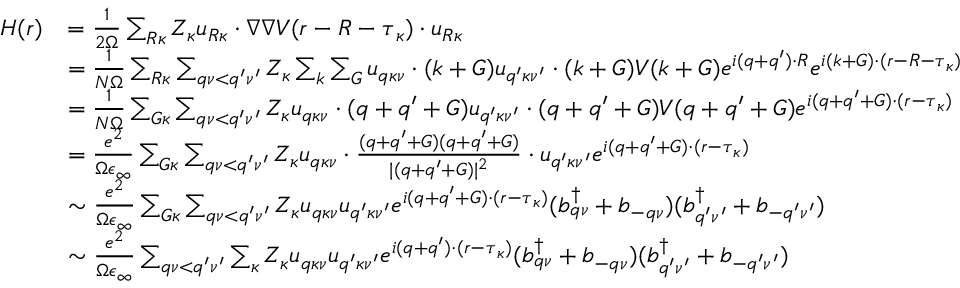<formula> <loc_0><loc_0><loc_500><loc_500>\begin{array} { r l } { H ( r ) } & { = \frac { 1 } { 2 \Omega } \sum _ { R \kappa } Z _ { \kappa } u _ { R \kappa } \cdot \nabla \nabla V ( r - R - \tau _ { \kappa } ) \cdot u _ { R \kappa } } \\ & { = \frac { 1 } { N \Omega } \sum _ { R \kappa } \sum _ { q \nu < q ^ { \prime } \nu ^ { \prime } } Z _ { \kappa } \sum _ { k } \sum _ { G } u _ { q \kappa \nu } \cdot ( k + G ) u _ { q ^ { \prime } \kappa \nu ^ { \prime } } \cdot ( k + G ) V ( k + G ) e ^ { i ( q + q ^ { \prime } ) \cdot R } e ^ { i ( k + G ) \cdot ( r - R - \tau _ { \kappa } ) } } \\ & { = \frac { 1 } { N \Omega } \sum _ { G \kappa } \sum _ { q \nu < q ^ { \prime } \nu ^ { \prime } } Z _ { \kappa } u _ { q \kappa \nu } \cdot ( q + q ^ { \prime } + G ) u _ { q ^ { \prime } \kappa \nu ^ { \prime } } \cdot ( q + q ^ { \prime } + G ) V ( q + q ^ { \prime } + G ) e ^ { i ( q + q ^ { \prime } + G ) \cdot ( r - \tau _ { \kappa } ) } } \\ & { = \frac { e ^ { 2 } } { \Omega \epsilon _ { \infty } } \sum _ { G \kappa } \sum _ { q \nu < q ^ { \prime } \nu ^ { \prime } } Z _ { \kappa } u _ { q \kappa \nu } \cdot \frac { ( q + q ^ { \prime } + G ) ( q + q ^ { \prime } + G ) } { | ( q + q ^ { \prime } + G ) | ^ { 2 } } \cdot u _ { q ^ { \prime } \kappa \nu ^ { \prime } } e ^ { i ( q + q ^ { \prime } + G ) \cdot ( r - \tau _ { \kappa } ) } } \\ & { \sim \frac { e ^ { 2 } } { \Omega \epsilon _ { \infty } } \sum _ { G \kappa } \sum _ { q \nu < q ^ { \prime } \nu ^ { \prime } } Z _ { \kappa } u _ { q \kappa \nu } u _ { q ^ { \prime } \kappa \nu ^ { \prime } } e ^ { i ( q + q ^ { \prime } + G ) \cdot ( r - \tau _ { \kappa } ) } ( b _ { q \nu } ^ { \dagger } + b _ { - q \nu } ) ( b _ { q ^ { \prime } \nu ^ { \prime } } ^ { \dagger } + b _ { - q ^ { \prime } \nu ^ { \prime } } ) } \\ & { \sim \frac { e ^ { 2 } } { \Omega \epsilon _ { \infty } } \sum _ { q \nu < q ^ { \prime } \nu ^ { \prime } } \sum _ { \kappa } Z _ { \kappa } u _ { q \kappa \nu } u _ { q ^ { \prime } \kappa \nu ^ { \prime } } e ^ { i ( q + q ^ { \prime } ) \cdot ( r - \tau _ { \kappa } ) } ( b _ { q \nu } ^ { \dagger } + b _ { - q \nu } ) ( b _ { q ^ { \prime } \nu ^ { \prime } } ^ { \dagger } + b _ { - q ^ { \prime } \nu ^ { \prime } } ) } \end{array}</formula> 